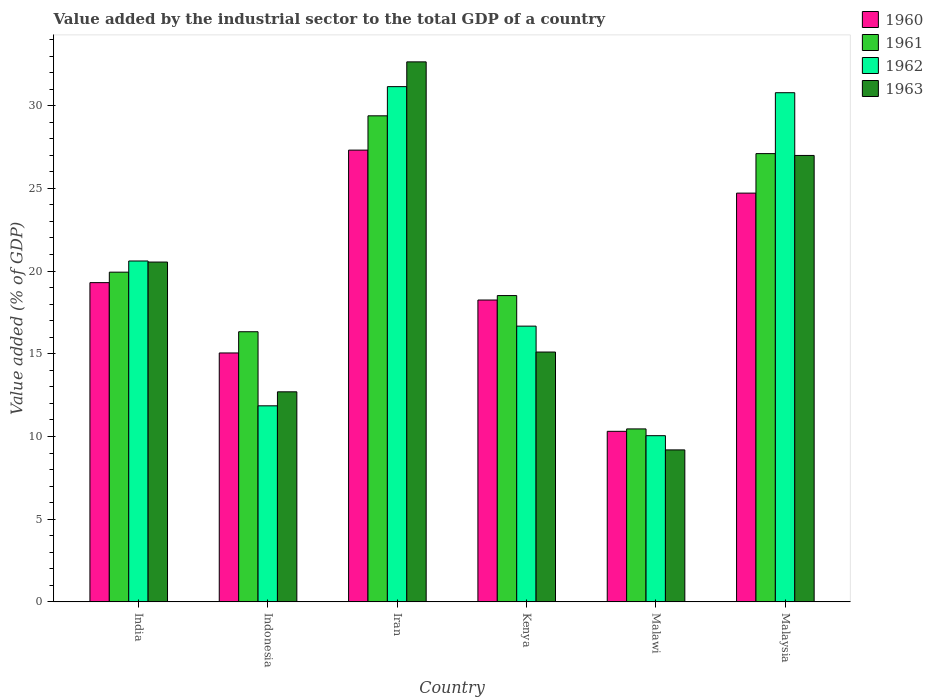How many different coloured bars are there?
Offer a terse response. 4. How many groups of bars are there?
Offer a very short reply. 6. How many bars are there on the 6th tick from the right?
Provide a succinct answer. 4. What is the label of the 2nd group of bars from the left?
Give a very brief answer. Indonesia. What is the value added by the industrial sector to the total GDP in 1960 in Indonesia?
Your response must be concise. 15.05. Across all countries, what is the maximum value added by the industrial sector to the total GDP in 1962?
Offer a very short reply. 31.15. Across all countries, what is the minimum value added by the industrial sector to the total GDP in 1961?
Give a very brief answer. 10.46. In which country was the value added by the industrial sector to the total GDP in 1961 maximum?
Provide a short and direct response. Iran. In which country was the value added by the industrial sector to the total GDP in 1962 minimum?
Give a very brief answer. Malawi. What is the total value added by the industrial sector to the total GDP in 1963 in the graph?
Provide a succinct answer. 117.17. What is the difference between the value added by the industrial sector to the total GDP in 1960 in Iran and that in Kenya?
Make the answer very short. 9.06. What is the difference between the value added by the industrial sector to the total GDP in 1963 in India and the value added by the industrial sector to the total GDP in 1962 in Malaysia?
Your answer should be very brief. -10.24. What is the average value added by the industrial sector to the total GDP in 1961 per country?
Your answer should be very brief. 20.29. What is the difference between the value added by the industrial sector to the total GDP of/in 1960 and value added by the industrial sector to the total GDP of/in 1962 in Malawi?
Your answer should be compact. 0.26. In how many countries, is the value added by the industrial sector to the total GDP in 1961 greater than 2 %?
Your answer should be very brief. 6. What is the ratio of the value added by the industrial sector to the total GDP in 1962 in India to that in Malawi?
Your answer should be very brief. 2.05. Is the value added by the industrial sector to the total GDP in 1961 in India less than that in Malawi?
Your answer should be compact. No. What is the difference between the highest and the second highest value added by the industrial sector to the total GDP in 1960?
Offer a terse response. 5.41. What is the difference between the highest and the lowest value added by the industrial sector to the total GDP in 1963?
Provide a succinct answer. 23.46. In how many countries, is the value added by the industrial sector to the total GDP in 1960 greater than the average value added by the industrial sector to the total GDP in 1960 taken over all countries?
Your response must be concise. 3. Is it the case that in every country, the sum of the value added by the industrial sector to the total GDP in 1962 and value added by the industrial sector to the total GDP in 1961 is greater than the sum of value added by the industrial sector to the total GDP in 1963 and value added by the industrial sector to the total GDP in 1960?
Offer a very short reply. No. What does the 2nd bar from the right in Kenya represents?
Offer a terse response. 1962. Are the values on the major ticks of Y-axis written in scientific E-notation?
Keep it short and to the point. No. Does the graph contain grids?
Your response must be concise. No. Where does the legend appear in the graph?
Keep it short and to the point. Top right. What is the title of the graph?
Offer a terse response. Value added by the industrial sector to the total GDP of a country. Does "1973" appear as one of the legend labels in the graph?
Your response must be concise. No. What is the label or title of the Y-axis?
Provide a short and direct response. Value added (% of GDP). What is the Value added (% of GDP) in 1960 in India?
Your response must be concise. 19.3. What is the Value added (% of GDP) in 1961 in India?
Offer a terse response. 19.93. What is the Value added (% of GDP) of 1962 in India?
Your answer should be compact. 20.61. What is the Value added (% of GDP) of 1963 in India?
Offer a very short reply. 20.54. What is the Value added (% of GDP) in 1960 in Indonesia?
Your answer should be very brief. 15.05. What is the Value added (% of GDP) in 1961 in Indonesia?
Give a very brief answer. 16.33. What is the Value added (% of GDP) of 1962 in Indonesia?
Keep it short and to the point. 11.85. What is the Value added (% of GDP) of 1963 in Indonesia?
Give a very brief answer. 12.7. What is the Value added (% of GDP) in 1960 in Iran?
Provide a short and direct response. 27.31. What is the Value added (% of GDP) of 1961 in Iran?
Give a very brief answer. 29.38. What is the Value added (% of GDP) in 1962 in Iran?
Make the answer very short. 31.15. What is the Value added (% of GDP) in 1963 in Iran?
Make the answer very short. 32.65. What is the Value added (% of GDP) of 1960 in Kenya?
Provide a succinct answer. 18.25. What is the Value added (% of GDP) in 1961 in Kenya?
Provide a short and direct response. 18.52. What is the Value added (% of GDP) of 1962 in Kenya?
Offer a terse response. 16.67. What is the Value added (% of GDP) of 1963 in Kenya?
Ensure brevity in your answer.  15.1. What is the Value added (% of GDP) in 1960 in Malawi?
Make the answer very short. 10.31. What is the Value added (% of GDP) in 1961 in Malawi?
Your answer should be very brief. 10.46. What is the Value added (% of GDP) of 1962 in Malawi?
Provide a succinct answer. 10.05. What is the Value added (% of GDP) of 1963 in Malawi?
Your answer should be compact. 9.19. What is the Value added (% of GDP) in 1960 in Malaysia?
Provide a succinct answer. 24.71. What is the Value added (% of GDP) in 1961 in Malaysia?
Your response must be concise. 27.1. What is the Value added (% of GDP) in 1962 in Malaysia?
Your answer should be compact. 30.78. What is the Value added (% of GDP) in 1963 in Malaysia?
Your response must be concise. 26.99. Across all countries, what is the maximum Value added (% of GDP) of 1960?
Offer a very short reply. 27.31. Across all countries, what is the maximum Value added (% of GDP) of 1961?
Make the answer very short. 29.38. Across all countries, what is the maximum Value added (% of GDP) of 1962?
Your answer should be compact. 31.15. Across all countries, what is the maximum Value added (% of GDP) in 1963?
Your answer should be compact. 32.65. Across all countries, what is the minimum Value added (% of GDP) in 1960?
Provide a short and direct response. 10.31. Across all countries, what is the minimum Value added (% of GDP) of 1961?
Give a very brief answer. 10.46. Across all countries, what is the minimum Value added (% of GDP) in 1962?
Provide a succinct answer. 10.05. Across all countries, what is the minimum Value added (% of GDP) of 1963?
Your response must be concise. 9.19. What is the total Value added (% of GDP) in 1960 in the graph?
Offer a terse response. 114.93. What is the total Value added (% of GDP) of 1961 in the graph?
Provide a short and direct response. 121.72. What is the total Value added (% of GDP) in 1962 in the graph?
Ensure brevity in your answer.  121.11. What is the total Value added (% of GDP) of 1963 in the graph?
Provide a short and direct response. 117.17. What is the difference between the Value added (% of GDP) in 1960 in India and that in Indonesia?
Make the answer very short. 4.25. What is the difference between the Value added (% of GDP) of 1961 in India and that in Indonesia?
Your response must be concise. 3.6. What is the difference between the Value added (% of GDP) in 1962 in India and that in Indonesia?
Your answer should be very brief. 8.76. What is the difference between the Value added (% of GDP) in 1963 in India and that in Indonesia?
Your response must be concise. 7.84. What is the difference between the Value added (% of GDP) in 1960 in India and that in Iran?
Your answer should be compact. -8.01. What is the difference between the Value added (% of GDP) in 1961 in India and that in Iran?
Ensure brevity in your answer.  -9.45. What is the difference between the Value added (% of GDP) of 1962 in India and that in Iran?
Make the answer very short. -10.54. What is the difference between the Value added (% of GDP) in 1963 in India and that in Iran?
Give a very brief answer. -12.1. What is the difference between the Value added (% of GDP) of 1960 in India and that in Kenya?
Provide a succinct answer. 1.05. What is the difference between the Value added (% of GDP) of 1961 in India and that in Kenya?
Provide a short and direct response. 1.42. What is the difference between the Value added (% of GDP) in 1962 in India and that in Kenya?
Keep it short and to the point. 3.94. What is the difference between the Value added (% of GDP) of 1963 in India and that in Kenya?
Offer a very short reply. 5.44. What is the difference between the Value added (% of GDP) of 1960 in India and that in Malawi?
Give a very brief answer. 8.99. What is the difference between the Value added (% of GDP) of 1961 in India and that in Malawi?
Give a very brief answer. 9.48. What is the difference between the Value added (% of GDP) in 1962 in India and that in Malawi?
Your response must be concise. 10.56. What is the difference between the Value added (% of GDP) in 1963 in India and that in Malawi?
Offer a very short reply. 11.36. What is the difference between the Value added (% of GDP) in 1960 in India and that in Malaysia?
Provide a short and direct response. -5.41. What is the difference between the Value added (% of GDP) of 1961 in India and that in Malaysia?
Make the answer very short. -7.17. What is the difference between the Value added (% of GDP) in 1962 in India and that in Malaysia?
Give a very brief answer. -10.17. What is the difference between the Value added (% of GDP) in 1963 in India and that in Malaysia?
Ensure brevity in your answer.  -6.45. What is the difference between the Value added (% of GDP) of 1960 in Indonesia and that in Iran?
Give a very brief answer. -12.26. What is the difference between the Value added (% of GDP) of 1961 in Indonesia and that in Iran?
Provide a short and direct response. -13.05. What is the difference between the Value added (% of GDP) in 1962 in Indonesia and that in Iran?
Offer a very short reply. -19.3. What is the difference between the Value added (% of GDP) of 1963 in Indonesia and that in Iran?
Your answer should be very brief. -19.95. What is the difference between the Value added (% of GDP) in 1960 in Indonesia and that in Kenya?
Keep it short and to the point. -3.2. What is the difference between the Value added (% of GDP) of 1961 in Indonesia and that in Kenya?
Offer a terse response. -2.19. What is the difference between the Value added (% of GDP) of 1962 in Indonesia and that in Kenya?
Give a very brief answer. -4.82. What is the difference between the Value added (% of GDP) of 1963 in Indonesia and that in Kenya?
Offer a terse response. -2.4. What is the difference between the Value added (% of GDP) in 1960 in Indonesia and that in Malawi?
Ensure brevity in your answer.  4.74. What is the difference between the Value added (% of GDP) in 1961 in Indonesia and that in Malawi?
Offer a terse response. 5.87. What is the difference between the Value added (% of GDP) in 1962 in Indonesia and that in Malawi?
Your answer should be very brief. 1.8. What is the difference between the Value added (% of GDP) of 1963 in Indonesia and that in Malawi?
Keep it short and to the point. 3.51. What is the difference between the Value added (% of GDP) of 1960 in Indonesia and that in Malaysia?
Keep it short and to the point. -9.66. What is the difference between the Value added (% of GDP) of 1961 in Indonesia and that in Malaysia?
Your answer should be very brief. -10.77. What is the difference between the Value added (% of GDP) in 1962 in Indonesia and that in Malaysia?
Your answer should be very brief. -18.93. What is the difference between the Value added (% of GDP) of 1963 in Indonesia and that in Malaysia?
Keep it short and to the point. -14.29. What is the difference between the Value added (% of GDP) of 1960 in Iran and that in Kenya?
Your response must be concise. 9.06. What is the difference between the Value added (% of GDP) in 1961 in Iran and that in Kenya?
Ensure brevity in your answer.  10.87. What is the difference between the Value added (% of GDP) in 1962 in Iran and that in Kenya?
Provide a short and direct response. 14.48. What is the difference between the Value added (% of GDP) of 1963 in Iran and that in Kenya?
Ensure brevity in your answer.  17.54. What is the difference between the Value added (% of GDP) of 1960 in Iran and that in Malawi?
Give a very brief answer. 17. What is the difference between the Value added (% of GDP) of 1961 in Iran and that in Malawi?
Your answer should be very brief. 18.93. What is the difference between the Value added (% of GDP) in 1962 in Iran and that in Malawi?
Your response must be concise. 21.1. What is the difference between the Value added (% of GDP) in 1963 in Iran and that in Malawi?
Give a very brief answer. 23.46. What is the difference between the Value added (% of GDP) of 1960 in Iran and that in Malaysia?
Offer a terse response. 2.6. What is the difference between the Value added (% of GDP) of 1961 in Iran and that in Malaysia?
Give a very brief answer. 2.29. What is the difference between the Value added (% of GDP) in 1962 in Iran and that in Malaysia?
Provide a short and direct response. 0.37. What is the difference between the Value added (% of GDP) in 1963 in Iran and that in Malaysia?
Give a very brief answer. 5.66. What is the difference between the Value added (% of GDP) in 1960 in Kenya and that in Malawi?
Provide a short and direct response. 7.94. What is the difference between the Value added (% of GDP) in 1961 in Kenya and that in Malawi?
Provide a succinct answer. 8.06. What is the difference between the Value added (% of GDP) of 1962 in Kenya and that in Malawi?
Your response must be concise. 6.62. What is the difference between the Value added (% of GDP) in 1963 in Kenya and that in Malawi?
Provide a succinct answer. 5.92. What is the difference between the Value added (% of GDP) of 1960 in Kenya and that in Malaysia?
Offer a very short reply. -6.46. What is the difference between the Value added (% of GDP) of 1961 in Kenya and that in Malaysia?
Offer a terse response. -8.58. What is the difference between the Value added (% of GDP) in 1962 in Kenya and that in Malaysia?
Provide a succinct answer. -14.11. What is the difference between the Value added (% of GDP) in 1963 in Kenya and that in Malaysia?
Keep it short and to the point. -11.88. What is the difference between the Value added (% of GDP) of 1960 in Malawi and that in Malaysia?
Make the answer very short. -14.4. What is the difference between the Value added (% of GDP) in 1961 in Malawi and that in Malaysia?
Your answer should be compact. -16.64. What is the difference between the Value added (% of GDP) in 1962 in Malawi and that in Malaysia?
Offer a very short reply. -20.73. What is the difference between the Value added (% of GDP) in 1963 in Malawi and that in Malaysia?
Offer a terse response. -17.8. What is the difference between the Value added (% of GDP) in 1960 in India and the Value added (% of GDP) in 1961 in Indonesia?
Make the answer very short. 2.97. What is the difference between the Value added (% of GDP) in 1960 in India and the Value added (% of GDP) in 1962 in Indonesia?
Ensure brevity in your answer.  7.45. What is the difference between the Value added (% of GDP) in 1960 in India and the Value added (% of GDP) in 1963 in Indonesia?
Provide a succinct answer. 6.6. What is the difference between the Value added (% of GDP) in 1961 in India and the Value added (% of GDP) in 1962 in Indonesia?
Offer a very short reply. 8.08. What is the difference between the Value added (% of GDP) in 1961 in India and the Value added (% of GDP) in 1963 in Indonesia?
Provide a short and direct response. 7.23. What is the difference between the Value added (% of GDP) of 1962 in India and the Value added (% of GDP) of 1963 in Indonesia?
Your response must be concise. 7.91. What is the difference between the Value added (% of GDP) in 1960 in India and the Value added (% of GDP) in 1961 in Iran?
Offer a very short reply. -10.09. What is the difference between the Value added (% of GDP) of 1960 in India and the Value added (% of GDP) of 1962 in Iran?
Offer a terse response. -11.85. What is the difference between the Value added (% of GDP) of 1960 in India and the Value added (% of GDP) of 1963 in Iran?
Your answer should be very brief. -13.35. What is the difference between the Value added (% of GDP) of 1961 in India and the Value added (% of GDP) of 1962 in Iran?
Give a very brief answer. -11.22. What is the difference between the Value added (% of GDP) in 1961 in India and the Value added (% of GDP) in 1963 in Iran?
Offer a terse response. -12.71. What is the difference between the Value added (% of GDP) in 1962 in India and the Value added (% of GDP) in 1963 in Iran?
Offer a very short reply. -12.04. What is the difference between the Value added (% of GDP) of 1960 in India and the Value added (% of GDP) of 1961 in Kenya?
Your answer should be compact. 0.78. What is the difference between the Value added (% of GDP) of 1960 in India and the Value added (% of GDP) of 1962 in Kenya?
Make the answer very short. 2.63. What is the difference between the Value added (% of GDP) of 1960 in India and the Value added (% of GDP) of 1963 in Kenya?
Ensure brevity in your answer.  4.2. What is the difference between the Value added (% of GDP) of 1961 in India and the Value added (% of GDP) of 1962 in Kenya?
Offer a very short reply. 3.26. What is the difference between the Value added (% of GDP) in 1961 in India and the Value added (% of GDP) in 1963 in Kenya?
Make the answer very short. 4.83. What is the difference between the Value added (% of GDP) of 1962 in India and the Value added (% of GDP) of 1963 in Kenya?
Your response must be concise. 5.5. What is the difference between the Value added (% of GDP) of 1960 in India and the Value added (% of GDP) of 1961 in Malawi?
Provide a short and direct response. 8.84. What is the difference between the Value added (% of GDP) of 1960 in India and the Value added (% of GDP) of 1962 in Malawi?
Provide a short and direct response. 9.25. What is the difference between the Value added (% of GDP) in 1960 in India and the Value added (% of GDP) in 1963 in Malawi?
Offer a very short reply. 10.11. What is the difference between the Value added (% of GDP) in 1961 in India and the Value added (% of GDP) in 1962 in Malawi?
Ensure brevity in your answer.  9.89. What is the difference between the Value added (% of GDP) in 1961 in India and the Value added (% of GDP) in 1963 in Malawi?
Offer a terse response. 10.75. What is the difference between the Value added (% of GDP) of 1962 in India and the Value added (% of GDP) of 1963 in Malawi?
Keep it short and to the point. 11.42. What is the difference between the Value added (% of GDP) in 1960 in India and the Value added (% of GDP) in 1961 in Malaysia?
Give a very brief answer. -7.8. What is the difference between the Value added (% of GDP) of 1960 in India and the Value added (% of GDP) of 1962 in Malaysia?
Make the answer very short. -11.48. What is the difference between the Value added (% of GDP) in 1960 in India and the Value added (% of GDP) in 1963 in Malaysia?
Keep it short and to the point. -7.69. What is the difference between the Value added (% of GDP) in 1961 in India and the Value added (% of GDP) in 1962 in Malaysia?
Give a very brief answer. -10.85. What is the difference between the Value added (% of GDP) of 1961 in India and the Value added (% of GDP) of 1963 in Malaysia?
Offer a terse response. -7.06. What is the difference between the Value added (% of GDP) of 1962 in India and the Value added (% of GDP) of 1963 in Malaysia?
Your answer should be very brief. -6.38. What is the difference between the Value added (% of GDP) of 1960 in Indonesia and the Value added (% of GDP) of 1961 in Iran?
Your response must be concise. -14.34. What is the difference between the Value added (% of GDP) of 1960 in Indonesia and the Value added (% of GDP) of 1962 in Iran?
Make the answer very short. -16.1. What is the difference between the Value added (% of GDP) in 1960 in Indonesia and the Value added (% of GDP) in 1963 in Iran?
Offer a terse response. -17.6. What is the difference between the Value added (% of GDP) in 1961 in Indonesia and the Value added (% of GDP) in 1962 in Iran?
Ensure brevity in your answer.  -14.82. What is the difference between the Value added (% of GDP) of 1961 in Indonesia and the Value added (% of GDP) of 1963 in Iran?
Keep it short and to the point. -16.32. What is the difference between the Value added (% of GDP) of 1962 in Indonesia and the Value added (% of GDP) of 1963 in Iran?
Ensure brevity in your answer.  -20.79. What is the difference between the Value added (% of GDP) in 1960 in Indonesia and the Value added (% of GDP) in 1961 in Kenya?
Provide a short and direct response. -3.47. What is the difference between the Value added (% of GDP) of 1960 in Indonesia and the Value added (% of GDP) of 1962 in Kenya?
Keep it short and to the point. -1.62. What is the difference between the Value added (% of GDP) of 1960 in Indonesia and the Value added (% of GDP) of 1963 in Kenya?
Your response must be concise. -0.06. What is the difference between the Value added (% of GDP) in 1961 in Indonesia and the Value added (% of GDP) in 1962 in Kenya?
Ensure brevity in your answer.  -0.34. What is the difference between the Value added (% of GDP) in 1961 in Indonesia and the Value added (% of GDP) in 1963 in Kenya?
Provide a short and direct response. 1.23. What is the difference between the Value added (% of GDP) in 1962 in Indonesia and the Value added (% of GDP) in 1963 in Kenya?
Ensure brevity in your answer.  -3.25. What is the difference between the Value added (% of GDP) of 1960 in Indonesia and the Value added (% of GDP) of 1961 in Malawi?
Offer a very short reply. 4.59. What is the difference between the Value added (% of GDP) in 1960 in Indonesia and the Value added (% of GDP) in 1962 in Malawi?
Make the answer very short. 5. What is the difference between the Value added (% of GDP) of 1960 in Indonesia and the Value added (% of GDP) of 1963 in Malawi?
Offer a terse response. 5.86. What is the difference between the Value added (% of GDP) in 1961 in Indonesia and the Value added (% of GDP) in 1962 in Malawi?
Provide a short and direct response. 6.28. What is the difference between the Value added (% of GDP) in 1961 in Indonesia and the Value added (% of GDP) in 1963 in Malawi?
Provide a short and direct response. 7.14. What is the difference between the Value added (% of GDP) of 1962 in Indonesia and the Value added (% of GDP) of 1963 in Malawi?
Your answer should be compact. 2.66. What is the difference between the Value added (% of GDP) of 1960 in Indonesia and the Value added (% of GDP) of 1961 in Malaysia?
Give a very brief answer. -12.05. What is the difference between the Value added (% of GDP) in 1960 in Indonesia and the Value added (% of GDP) in 1962 in Malaysia?
Offer a terse response. -15.73. What is the difference between the Value added (% of GDP) of 1960 in Indonesia and the Value added (% of GDP) of 1963 in Malaysia?
Provide a short and direct response. -11.94. What is the difference between the Value added (% of GDP) in 1961 in Indonesia and the Value added (% of GDP) in 1962 in Malaysia?
Make the answer very short. -14.45. What is the difference between the Value added (% of GDP) in 1961 in Indonesia and the Value added (% of GDP) in 1963 in Malaysia?
Your answer should be compact. -10.66. What is the difference between the Value added (% of GDP) in 1962 in Indonesia and the Value added (% of GDP) in 1963 in Malaysia?
Provide a short and direct response. -15.14. What is the difference between the Value added (% of GDP) in 1960 in Iran and the Value added (% of GDP) in 1961 in Kenya?
Your response must be concise. 8.79. What is the difference between the Value added (% of GDP) of 1960 in Iran and the Value added (% of GDP) of 1962 in Kenya?
Ensure brevity in your answer.  10.64. What is the difference between the Value added (% of GDP) in 1960 in Iran and the Value added (% of GDP) in 1963 in Kenya?
Make the answer very short. 12.21. What is the difference between the Value added (% of GDP) of 1961 in Iran and the Value added (% of GDP) of 1962 in Kenya?
Your answer should be very brief. 12.71. What is the difference between the Value added (% of GDP) of 1961 in Iran and the Value added (% of GDP) of 1963 in Kenya?
Give a very brief answer. 14.28. What is the difference between the Value added (% of GDP) in 1962 in Iran and the Value added (% of GDP) in 1963 in Kenya?
Provide a short and direct response. 16.04. What is the difference between the Value added (% of GDP) in 1960 in Iran and the Value added (% of GDP) in 1961 in Malawi?
Ensure brevity in your answer.  16.86. What is the difference between the Value added (% of GDP) of 1960 in Iran and the Value added (% of GDP) of 1962 in Malawi?
Your answer should be compact. 17.26. What is the difference between the Value added (% of GDP) of 1960 in Iran and the Value added (% of GDP) of 1963 in Malawi?
Your response must be concise. 18.12. What is the difference between the Value added (% of GDP) of 1961 in Iran and the Value added (% of GDP) of 1962 in Malawi?
Provide a short and direct response. 19.34. What is the difference between the Value added (% of GDP) in 1961 in Iran and the Value added (% of GDP) in 1963 in Malawi?
Make the answer very short. 20.2. What is the difference between the Value added (% of GDP) in 1962 in Iran and the Value added (% of GDP) in 1963 in Malawi?
Make the answer very short. 21.96. What is the difference between the Value added (% of GDP) in 1960 in Iran and the Value added (% of GDP) in 1961 in Malaysia?
Offer a very short reply. 0.21. What is the difference between the Value added (% of GDP) of 1960 in Iran and the Value added (% of GDP) of 1962 in Malaysia?
Give a very brief answer. -3.47. What is the difference between the Value added (% of GDP) of 1960 in Iran and the Value added (% of GDP) of 1963 in Malaysia?
Make the answer very short. 0.32. What is the difference between the Value added (% of GDP) in 1961 in Iran and the Value added (% of GDP) in 1962 in Malaysia?
Your answer should be very brief. -1.4. What is the difference between the Value added (% of GDP) in 1961 in Iran and the Value added (% of GDP) in 1963 in Malaysia?
Keep it short and to the point. 2.4. What is the difference between the Value added (% of GDP) in 1962 in Iran and the Value added (% of GDP) in 1963 in Malaysia?
Keep it short and to the point. 4.16. What is the difference between the Value added (% of GDP) in 1960 in Kenya and the Value added (% of GDP) in 1961 in Malawi?
Ensure brevity in your answer.  7.79. What is the difference between the Value added (% of GDP) of 1960 in Kenya and the Value added (% of GDP) of 1962 in Malawi?
Offer a very short reply. 8.2. What is the difference between the Value added (% of GDP) in 1960 in Kenya and the Value added (% of GDP) in 1963 in Malawi?
Ensure brevity in your answer.  9.06. What is the difference between the Value added (% of GDP) of 1961 in Kenya and the Value added (% of GDP) of 1962 in Malawi?
Provide a short and direct response. 8.47. What is the difference between the Value added (% of GDP) of 1961 in Kenya and the Value added (% of GDP) of 1963 in Malawi?
Provide a succinct answer. 9.33. What is the difference between the Value added (% of GDP) in 1962 in Kenya and the Value added (% of GDP) in 1963 in Malawi?
Make the answer very short. 7.48. What is the difference between the Value added (% of GDP) in 1960 in Kenya and the Value added (% of GDP) in 1961 in Malaysia?
Provide a short and direct response. -8.85. What is the difference between the Value added (% of GDP) in 1960 in Kenya and the Value added (% of GDP) in 1962 in Malaysia?
Ensure brevity in your answer.  -12.53. What is the difference between the Value added (% of GDP) of 1960 in Kenya and the Value added (% of GDP) of 1963 in Malaysia?
Make the answer very short. -8.74. What is the difference between the Value added (% of GDP) of 1961 in Kenya and the Value added (% of GDP) of 1962 in Malaysia?
Provide a succinct answer. -12.26. What is the difference between the Value added (% of GDP) in 1961 in Kenya and the Value added (% of GDP) in 1963 in Malaysia?
Your response must be concise. -8.47. What is the difference between the Value added (% of GDP) in 1962 in Kenya and the Value added (% of GDP) in 1963 in Malaysia?
Ensure brevity in your answer.  -10.32. What is the difference between the Value added (% of GDP) of 1960 in Malawi and the Value added (% of GDP) of 1961 in Malaysia?
Provide a short and direct response. -16.79. What is the difference between the Value added (% of GDP) of 1960 in Malawi and the Value added (% of GDP) of 1962 in Malaysia?
Your answer should be compact. -20.47. What is the difference between the Value added (% of GDP) in 1960 in Malawi and the Value added (% of GDP) in 1963 in Malaysia?
Make the answer very short. -16.68. What is the difference between the Value added (% of GDP) of 1961 in Malawi and the Value added (% of GDP) of 1962 in Malaysia?
Offer a very short reply. -20.33. What is the difference between the Value added (% of GDP) in 1961 in Malawi and the Value added (% of GDP) in 1963 in Malaysia?
Your answer should be very brief. -16.53. What is the difference between the Value added (% of GDP) in 1962 in Malawi and the Value added (% of GDP) in 1963 in Malaysia?
Your answer should be very brief. -16.94. What is the average Value added (% of GDP) of 1960 per country?
Keep it short and to the point. 19.16. What is the average Value added (% of GDP) of 1961 per country?
Ensure brevity in your answer.  20.29. What is the average Value added (% of GDP) in 1962 per country?
Offer a very short reply. 20.18. What is the average Value added (% of GDP) in 1963 per country?
Ensure brevity in your answer.  19.53. What is the difference between the Value added (% of GDP) of 1960 and Value added (% of GDP) of 1961 in India?
Your response must be concise. -0.63. What is the difference between the Value added (% of GDP) in 1960 and Value added (% of GDP) in 1962 in India?
Provide a succinct answer. -1.31. What is the difference between the Value added (% of GDP) of 1960 and Value added (% of GDP) of 1963 in India?
Make the answer very short. -1.24. What is the difference between the Value added (% of GDP) in 1961 and Value added (% of GDP) in 1962 in India?
Make the answer very short. -0.68. What is the difference between the Value added (% of GDP) of 1961 and Value added (% of GDP) of 1963 in India?
Keep it short and to the point. -0.61. What is the difference between the Value added (% of GDP) in 1962 and Value added (% of GDP) in 1963 in India?
Make the answer very short. 0.06. What is the difference between the Value added (% of GDP) of 1960 and Value added (% of GDP) of 1961 in Indonesia?
Make the answer very short. -1.28. What is the difference between the Value added (% of GDP) in 1960 and Value added (% of GDP) in 1962 in Indonesia?
Ensure brevity in your answer.  3.2. What is the difference between the Value added (% of GDP) in 1960 and Value added (% of GDP) in 1963 in Indonesia?
Give a very brief answer. 2.35. What is the difference between the Value added (% of GDP) in 1961 and Value added (% of GDP) in 1962 in Indonesia?
Provide a short and direct response. 4.48. What is the difference between the Value added (% of GDP) in 1961 and Value added (% of GDP) in 1963 in Indonesia?
Your response must be concise. 3.63. What is the difference between the Value added (% of GDP) in 1962 and Value added (% of GDP) in 1963 in Indonesia?
Ensure brevity in your answer.  -0.85. What is the difference between the Value added (% of GDP) in 1960 and Value added (% of GDP) in 1961 in Iran?
Ensure brevity in your answer.  -2.07. What is the difference between the Value added (% of GDP) of 1960 and Value added (% of GDP) of 1962 in Iran?
Provide a succinct answer. -3.84. What is the difference between the Value added (% of GDP) in 1960 and Value added (% of GDP) in 1963 in Iran?
Keep it short and to the point. -5.33. What is the difference between the Value added (% of GDP) of 1961 and Value added (% of GDP) of 1962 in Iran?
Your answer should be compact. -1.76. What is the difference between the Value added (% of GDP) of 1961 and Value added (% of GDP) of 1963 in Iran?
Make the answer very short. -3.26. What is the difference between the Value added (% of GDP) of 1962 and Value added (% of GDP) of 1963 in Iran?
Offer a terse response. -1.5. What is the difference between the Value added (% of GDP) of 1960 and Value added (% of GDP) of 1961 in Kenya?
Provide a short and direct response. -0.27. What is the difference between the Value added (% of GDP) of 1960 and Value added (% of GDP) of 1962 in Kenya?
Your response must be concise. 1.58. What is the difference between the Value added (% of GDP) of 1960 and Value added (% of GDP) of 1963 in Kenya?
Offer a very short reply. 3.14. What is the difference between the Value added (% of GDP) in 1961 and Value added (% of GDP) in 1962 in Kenya?
Offer a very short reply. 1.85. What is the difference between the Value added (% of GDP) of 1961 and Value added (% of GDP) of 1963 in Kenya?
Your answer should be compact. 3.41. What is the difference between the Value added (% of GDP) in 1962 and Value added (% of GDP) in 1963 in Kenya?
Provide a short and direct response. 1.57. What is the difference between the Value added (% of GDP) of 1960 and Value added (% of GDP) of 1961 in Malawi?
Keep it short and to the point. -0.15. What is the difference between the Value added (% of GDP) in 1960 and Value added (% of GDP) in 1962 in Malawi?
Give a very brief answer. 0.26. What is the difference between the Value added (% of GDP) in 1960 and Value added (% of GDP) in 1963 in Malawi?
Give a very brief answer. 1.12. What is the difference between the Value added (% of GDP) in 1961 and Value added (% of GDP) in 1962 in Malawi?
Give a very brief answer. 0.41. What is the difference between the Value added (% of GDP) of 1961 and Value added (% of GDP) of 1963 in Malawi?
Provide a succinct answer. 1.27. What is the difference between the Value added (% of GDP) of 1962 and Value added (% of GDP) of 1963 in Malawi?
Offer a very short reply. 0.86. What is the difference between the Value added (% of GDP) of 1960 and Value added (% of GDP) of 1961 in Malaysia?
Your response must be concise. -2.39. What is the difference between the Value added (% of GDP) in 1960 and Value added (% of GDP) in 1962 in Malaysia?
Provide a succinct answer. -6.07. What is the difference between the Value added (% of GDP) in 1960 and Value added (% of GDP) in 1963 in Malaysia?
Make the answer very short. -2.28. What is the difference between the Value added (% of GDP) of 1961 and Value added (% of GDP) of 1962 in Malaysia?
Your answer should be compact. -3.68. What is the difference between the Value added (% of GDP) of 1961 and Value added (% of GDP) of 1963 in Malaysia?
Your answer should be very brief. 0.11. What is the difference between the Value added (% of GDP) in 1962 and Value added (% of GDP) in 1963 in Malaysia?
Offer a very short reply. 3.79. What is the ratio of the Value added (% of GDP) in 1960 in India to that in Indonesia?
Offer a terse response. 1.28. What is the ratio of the Value added (% of GDP) in 1961 in India to that in Indonesia?
Your answer should be compact. 1.22. What is the ratio of the Value added (% of GDP) in 1962 in India to that in Indonesia?
Your response must be concise. 1.74. What is the ratio of the Value added (% of GDP) in 1963 in India to that in Indonesia?
Ensure brevity in your answer.  1.62. What is the ratio of the Value added (% of GDP) in 1960 in India to that in Iran?
Offer a terse response. 0.71. What is the ratio of the Value added (% of GDP) of 1961 in India to that in Iran?
Make the answer very short. 0.68. What is the ratio of the Value added (% of GDP) of 1962 in India to that in Iran?
Your answer should be compact. 0.66. What is the ratio of the Value added (% of GDP) of 1963 in India to that in Iran?
Your answer should be compact. 0.63. What is the ratio of the Value added (% of GDP) of 1960 in India to that in Kenya?
Ensure brevity in your answer.  1.06. What is the ratio of the Value added (% of GDP) of 1961 in India to that in Kenya?
Your response must be concise. 1.08. What is the ratio of the Value added (% of GDP) in 1962 in India to that in Kenya?
Keep it short and to the point. 1.24. What is the ratio of the Value added (% of GDP) in 1963 in India to that in Kenya?
Give a very brief answer. 1.36. What is the ratio of the Value added (% of GDP) of 1960 in India to that in Malawi?
Keep it short and to the point. 1.87. What is the ratio of the Value added (% of GDP) of 1961 in India to that in Malawi?
Keep it short and to the point. 1.91. What is the ratio of the Value added (% of GDP) of 1962 in India to that in Malawi?
Make the answer very short. 2.05. What is the ratio of the Value added (% of GDP) in 1963 in India to that in Malawi?
Keep it short and to the point. 2.24. What is the ratio of the Value added (% of GDP) of 1960 in India to that in Malaysia?
Make the answer very short. 0.78. What is the ratio of the Value added (% of GDP) of 1961 in India to that in Malaysia?
Your answer should be very brief. 0.74. What is the ratio of the Value added (% of GDP) of 1962 in India to that in Malaysia?
Your answer should be compact. 0.67. What is the ratio of the Value added (% of GDP) of 1963 in India to that in Malaysia?
Provide a succinct answer. 0.76. What is the ratio of the Value added (% of GDP) in 1960 in Indonesia to that in Iran?
Make the answer very short. 0.55. What is the ratio of the Value added (% of GDP) in 1961 in Indonesia to that in Iran?
Your response must be concise. 0.56. What is the ratio of the Value added (% of GDP) in 1962 in Indonesia to that in Iran?
Your response must be concise. 0.38. What is the ratio of the Value added (% of GDP) of 1963 in Indonesia to that in Iran?
Make the answer very short. 0.39. What is the ratio of the Value added (% of GDP) of 1960 in Indonesia to that in Kenya?
Offer a terse response. 0.82. What is the ratio of the Value added (% of GDP) of 1961 in Indonesia to that in Kenya?
Offer a very short reply. 0.88. What is the ratio of the Value added (% of GDP) in 1962 in Indonesia to that in Kenya?
Ensure brevity in your answer.  0.71. What is the ratio of the Value added (% of GDP) in 1963 in Indonesia to that in Kenya?
Ensure brevity in your answer.  0.84. What is the ratio of the Value added (% of GDP) of 1960 in Indonesia to that in Malawi?
Your response must be concise. 1.46. What is the ratio of the Value added (% of GDP) in 1961 in Indonesia to that in Malawi?
Your answer should be very brief. 1.56. What is the ratio of the Value added (% of GDP) in 1962 in Indonesia to that in Malawi?
Keep it short and to the point. 1.18. What is the ratio of the Value added (% of GDP) in 1963 in Indonesia to that in Malawi?
Your response must be concise. 1.38. What is the ratio of the Value added (% of GDP) of 1960 in Indonesia to that in Malaysia?
Offer a very short reply. 0.61. What is the ratio of the Value added (% of GDP) of 1961 in Indonesia to that in Malaysia?
Your answer should be compact. 0.6. What is the ratio of the Value added (% of GDP) in 1962 in Indonesia to that in Malaysia?
Provide a short and direct response. 0.39. What is the ratio of the Value added (% of GDP) in 1963 in Indonesia to that in Malaysia?
Your answer should be compact. 0.47. What is the ratio of the Value added (% of GDP) in 1960 in Iran to that in Kenya?
Provide a short and direct response. 1.5. What is the ratio of the Value added (% of GDP) in 1961 in Iran to that in Kenya?
Your answer should be compact. 1.59. What is the ratio of the Value added (% of GDP) of 1962 in Iran to that in Kenya?
Provide a succinct answer. 1.87. What is the ratio of the Value added (% of GDP) of 1963 in Iran to that in Kenya?
Your response must be concise. 2.16. What is the ratio of the Value added (% of GDP) in 1960 in Iran to that in Malawi?
Provide a succinct answer. 2.65. What is the ratio of the Value added (% of GDP) of 1961 in Iran to that in Malawi?
Your response must be concise. 2.81. What is the ratio of the Value added (% of GDP) of 1962 in Iran to that in Malawi?
Your answer should be compact. 3.1. What is the ratio of the Value added (% of GDP) in 1963 in Iran to that in Malawi?
Your answer should be very brief. 3.55. What is the ratio of the Value added (% of GDP) of 1960 in Iran to that in Malaysia?
Your answer should be very brief. 1.11. What is the ratio of the Value added (% of GDP) in 1961 in Iran to that in Malaysia?
Make the answer very short. 1.08. What is the ratio of the Value added (% of GDP) in 1962 in Iran to that in Malaysia?
Give a very brief answer. 1.01. What is the ratio of the Value added (% of GDP) in 1963 in Iran to that in Malaysia?
Provide a short and direct response. 1.21. What is the ratio of the Value added (% of GDP) in 1960 in Kenya to that in Malawi?
Offer a terse response. 1.77. What is the ratio of the Value added (% of GDP) in 1961 in Kenya to that in Malawi?
Make the answer very short. 1.77. What is the ratio of the Value added (% of GDP) of 1962 in Kenya to that in Malawi?
Provide a short and direct response. 1.66. What is the ratio of the Value added (% of GDP) in 1963 in Kenya to that in Malawi?
Your response must be concise. 1.64. What is the ratio of the Value added (% of GDP) in 1960 in Kenya to that in Malaysia?
Offer a very short reply. 0.74. What is the ratio of the Value added (% of GDP) of 1961 in Kenya to that in Malaysia?
Provide a succinct answer. 0.68. What is the ratio of the Value added (% of GDP) of 1962 in Kenya to that in Malaysia?
Your answer should be compact. 0.54. What is the ratio of the Value added (% of GDP) of 1963 in Kenya to that in Malaysia?
Make the answer very short. 0.56. What is the ratio of the Value added (% of GDP) of 1960 in Malawi to that in Malaysia?
Offer a terse response. 0.42. What is the ratio of the Value added (% of GDP) of 1961 in Malawi to that in Malaysia?
Offer a very short reply. 0.39. What is the ratio of the Value added (% of GDP) of 1962 in Malawi to that in Malaysia?
Your response must be concise. 0.33. What is the ratio of the Value added (% of GDP) in 1963 in Malawi to that in Malaysia?
Offer a terse response. 0.34. What is the difference between the highest and the second highest Value added (% of GDP) of 1960?
Ensure brevity in your answer.  2.6. What is the difference between the highest and the second highest Value added (% of GDP) in 1961?
Your answer should be compact. 2.29. What is the difference between the highest and the second highest Value added (% of GDP) in 1962?
Give a very brief answer. 0.37. What is the difference between the highest and the second highest Value added (% of GDP) of 1963?
Provide a succinct answer. 5.66. What is the difference between the highest and the lowest Value added (% of GDP) of 1960?
Provide a short and direct response. 17. What is the difference between the highest and the lowest Value added (% of GDP) of 1961?
Make the answer very short. 18.93. What is the difference between the highest and the lowest Value added (% of GDP) in 1962?
Offer a very short reply. 21.1. What is the difference between the highest and the lowest Value added (% of GDP) of 1963?
Your answer should be compact. 23.46. 